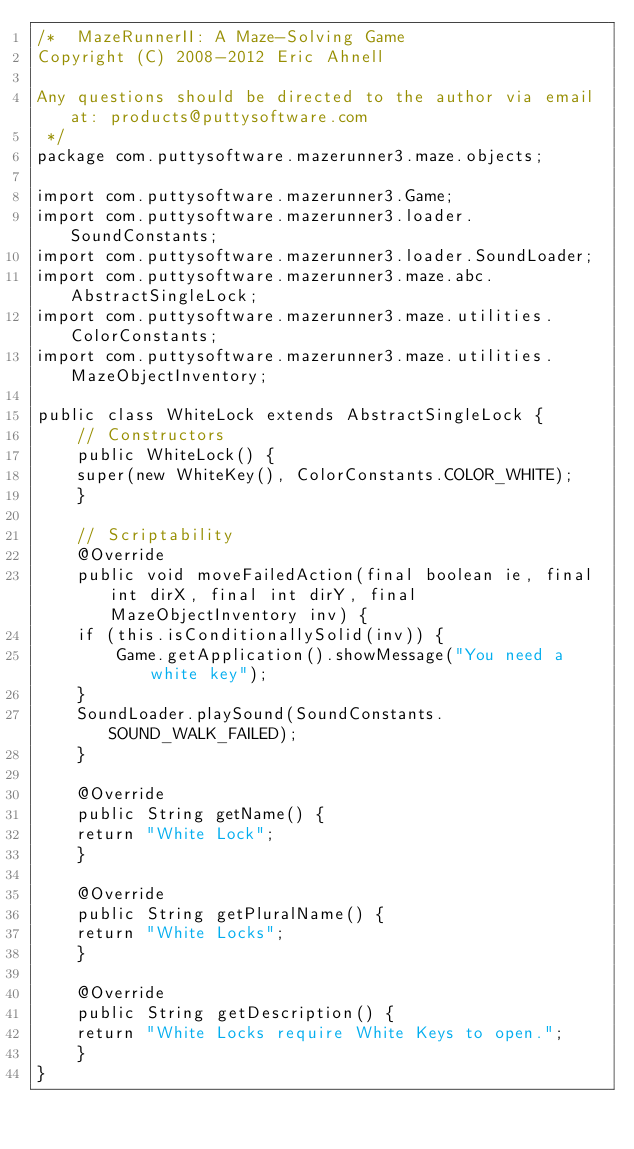Convert code to text. <code><loc_0><loc_0><loc_500><loc_500><_Java_>/*  MazeRunnerII: A Maze-Solving Game
Copyright (C) 2008-2012 Eric Ahnell

Any questions should be directed to the author via email at: products@puttysoftware.com
 */
package com.puttysoftware.mazerunner3.maze.objects;

import com.puttysoftware.mazerunner3.Game;
import com.puttysoftware.mazerunner3.loader.SoundConstants;
import com.puttysoftware.mazerunner3.loader.SoundLoader;
import com.puttysoftware.mazerunner3.maze.abc.AbstractSingleLock;
import com.puttysoftware.mazerunner3.maze.utilities.ColorConstants;
import com.puttysoftware.mazerunner3.maze.utilities.MazeObjectInventory;

public class WhiteLock extends AbstractSingleLock {
    // Constructors
    public WhiteLock() {
	super(new WhiteKey(), ColorConstants.COLOR_WHITE);
    }

    // Scriptability
    @Override
    public void moveFailedAction(final boolean ie, final int dirX, final int dirY, final MazeObjectInventory inv) {
	if (this.isConditionallySolid(inv)) {
	    Game.getApplication().showMessage("You need a white key");
	}
	SoundLoader.playSound(SoundConstants.SOUND_WALK_FAILED);
    }

    @Override
    public String getName() {
	return "White Lock";
    }

    @Override
    public String getPluralName() {
	return "White Locks";
    }

    @Override
    public String getDescription() {
	return "White Locks require White Keys to open.";
    }
}</code> 